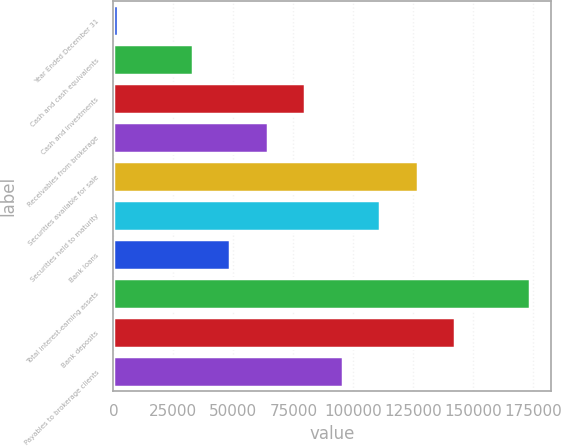<chart> <loc_0><loc_0><loc_500><loc_500><bar_chart><fcel>Year Ended December 31<fcel>Cash and cash equivalents<fcel>Cash and investments<fcel>Receivables from brokerage<fcel>Securities available for sale<fcel>Securities held to maturity<fcel>Bank loans<fcel>Total interest-earning assets<fcel>Bank deposits<fcel>Payables to brokerage clients<nl><fcel>2015<fcel>33202.4<fcel>79983.5<fcel>64389.8<fcel>126765<fcel>111171<fcel>48796.1<fcel>173546<fcel>142358<fcel>95577.2<nl></chart> 